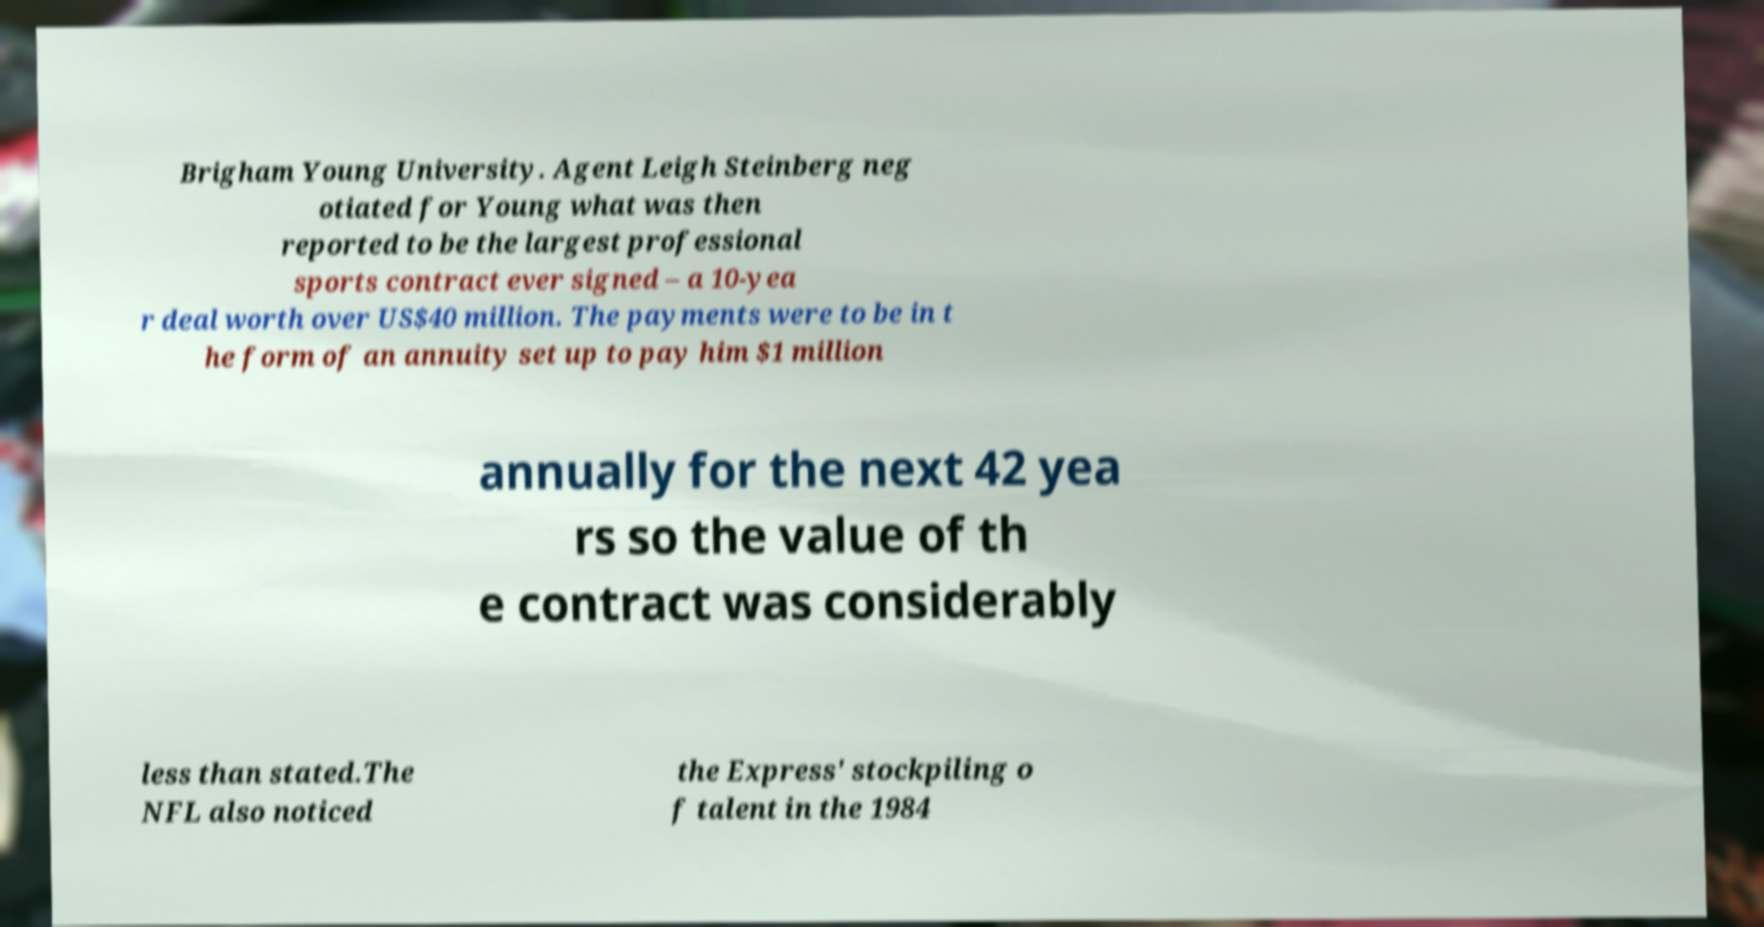I need the written content from this picture converted into text. Can you do that? Brigham Young University. Agent Leigh Steinberg neg otiated for Young what was then reported to be the largest professional sports contract ever signed – a 10-yea r deal worth over US$40 million. The payments were to be in t he form of an annuity set up to pay him $1 million annually for the next 42 yea rs so the value of th e contract was considerably less than stated.The NFL also noticed the Express' stockpiling o f talent in the 1984 